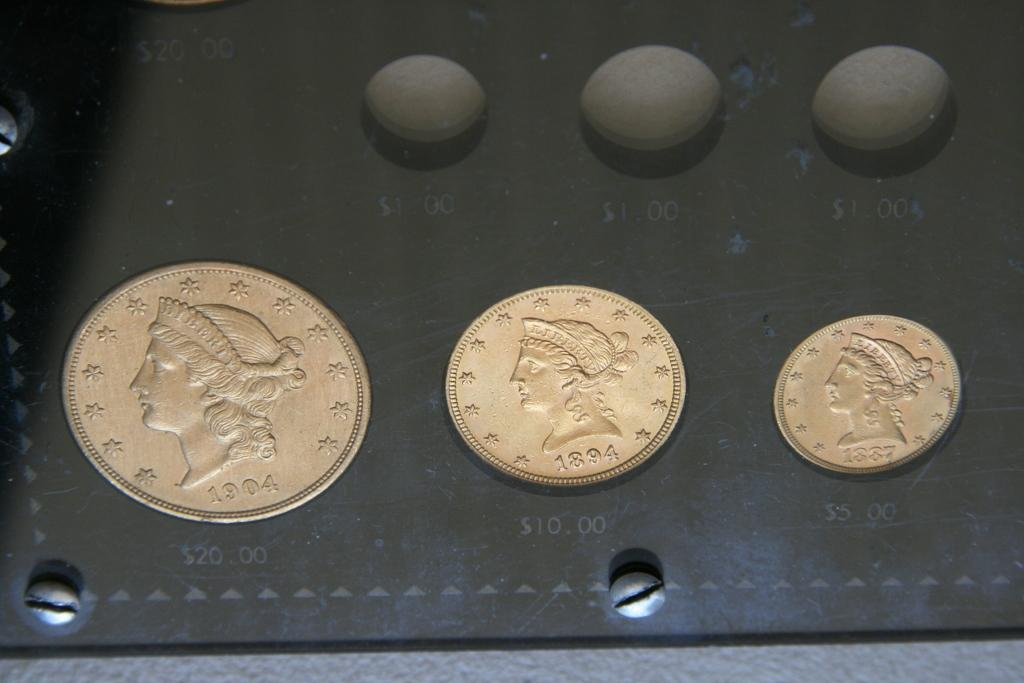What is the main subject of the image? The main subject of the image is coins with numbers and images in the center. Can you describe the appearance of the coins? The coins have numbers and images in the center. What color are the objects at the top of the image? The objects at the top of the image are black in color. How does the town react to the earthquake in the image? There is no town or earthquake present in the image; it only features coins with numbers and images, and black objects at the top. 